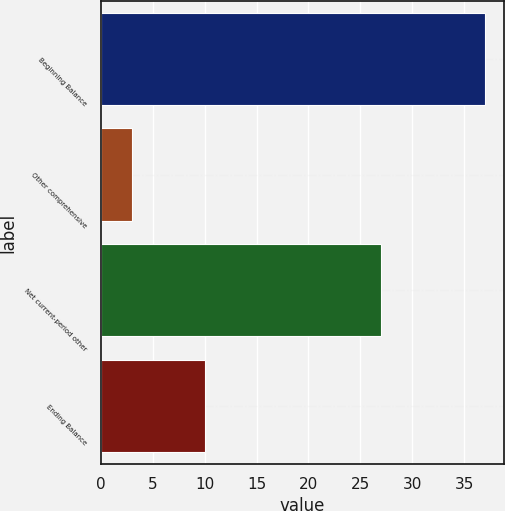<chart> <loc_0><loc_0><loc_500><loc_500><bar_chart><fcel>Beginning Balance<fcel>Other comprehensive<fcel>Net current-period other<fcel>Ending Balance<nl><fcel>37<fcel>3<fcel>27<fcel>10<nl></chart> 